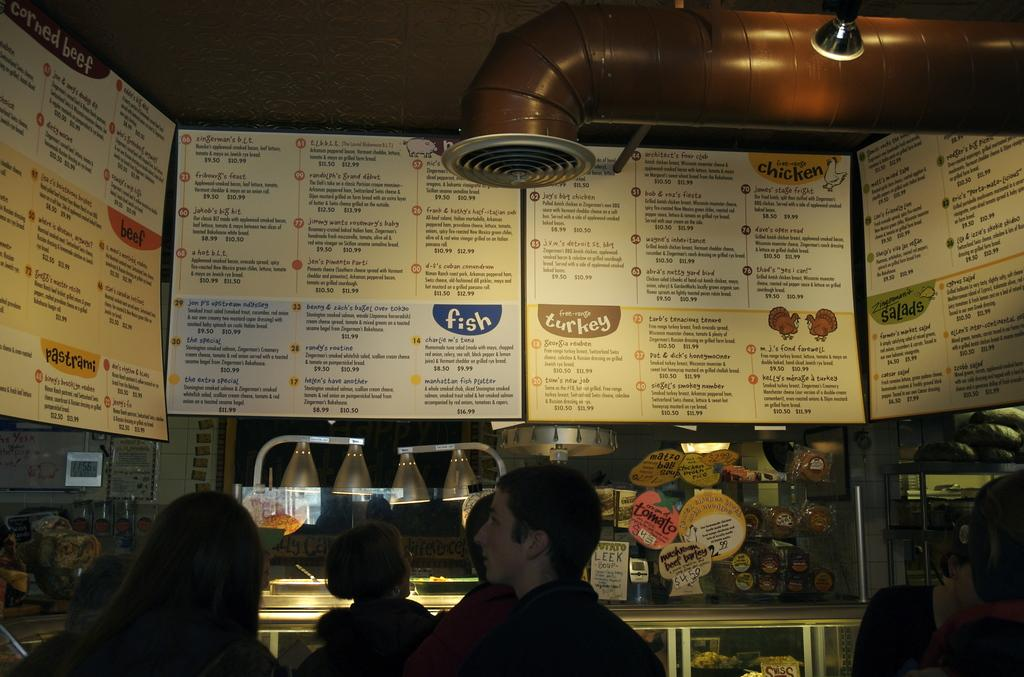What decorative elements can be seen in the image? There are banners in the image. What else can be seen in the image besides the banners? There are lights in the image. Are there any people present in the image? Yes, there are people present in the image. What type of corn can be seen growing in the image? There is no corn present in the image. How does the zebra interact with the people in the image? There is no zebra present in the image. 